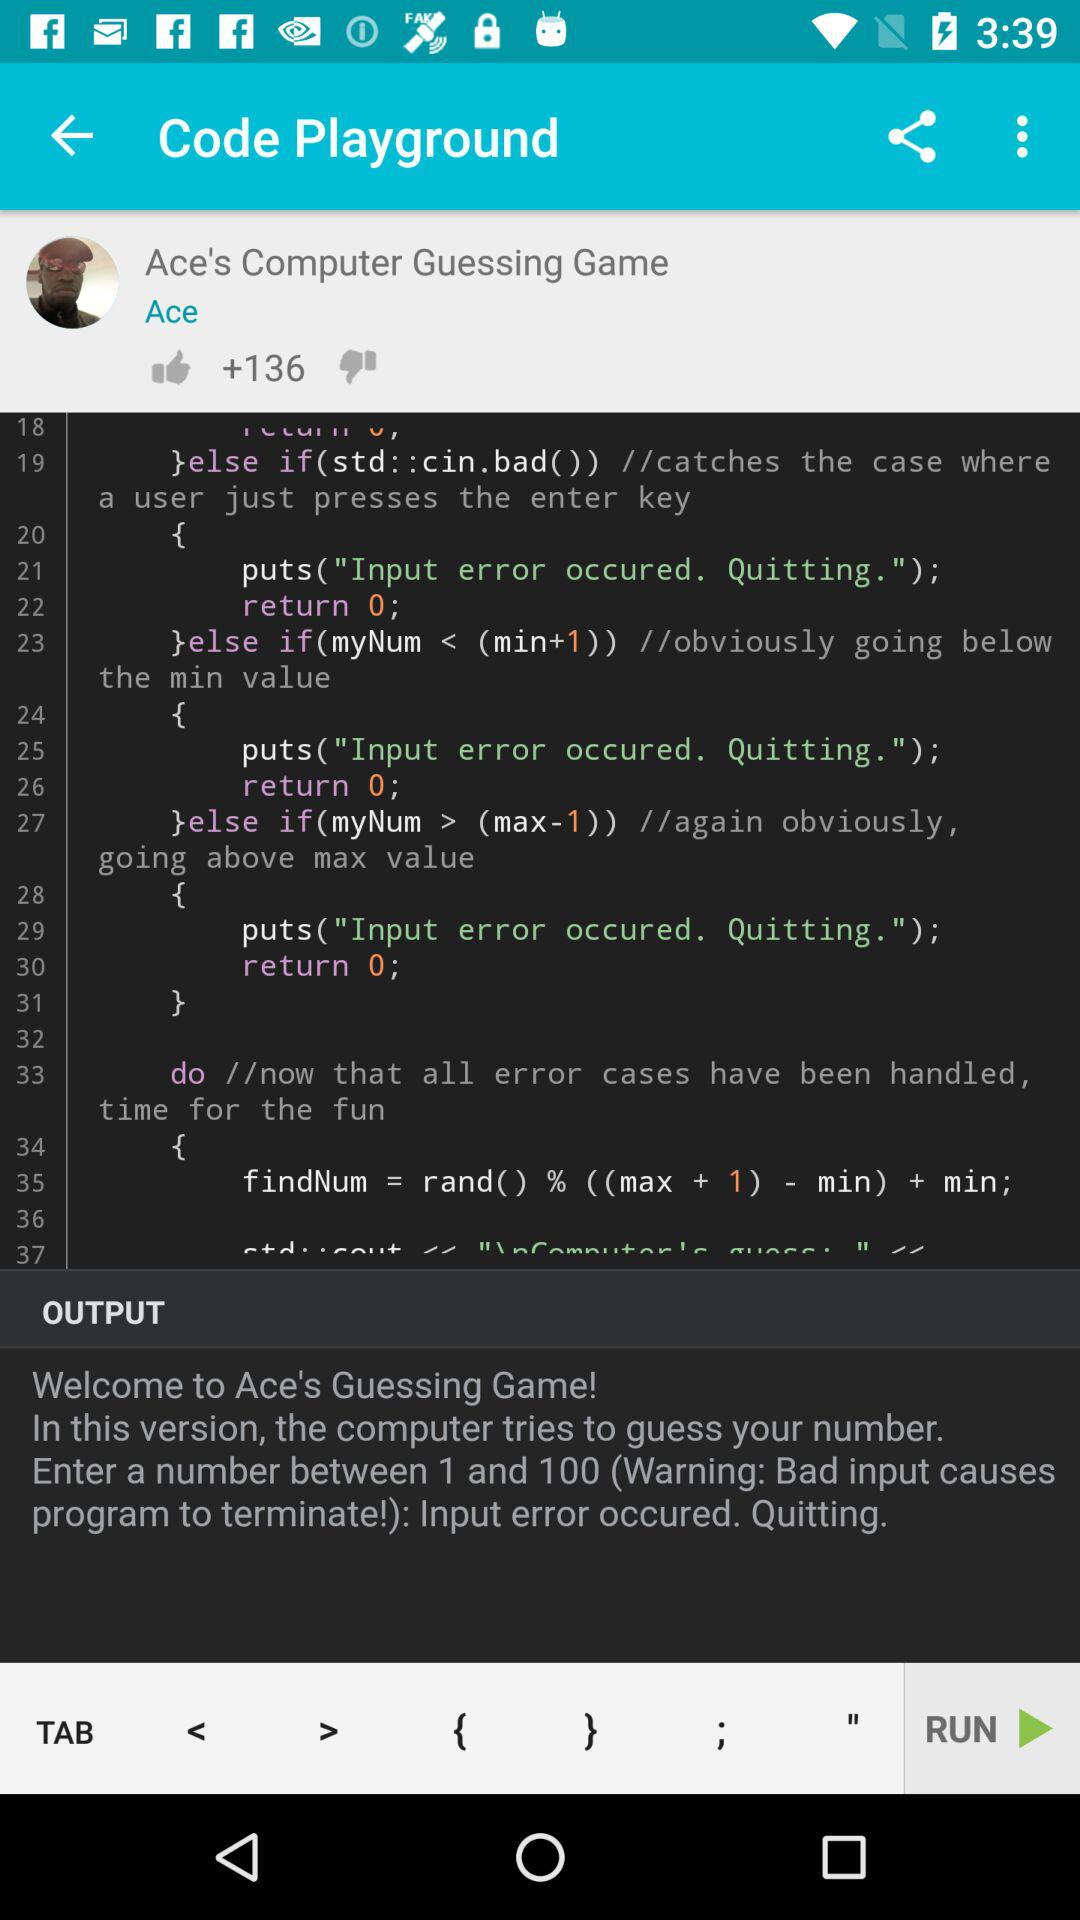How many likes are there? There are "+136" likes. 